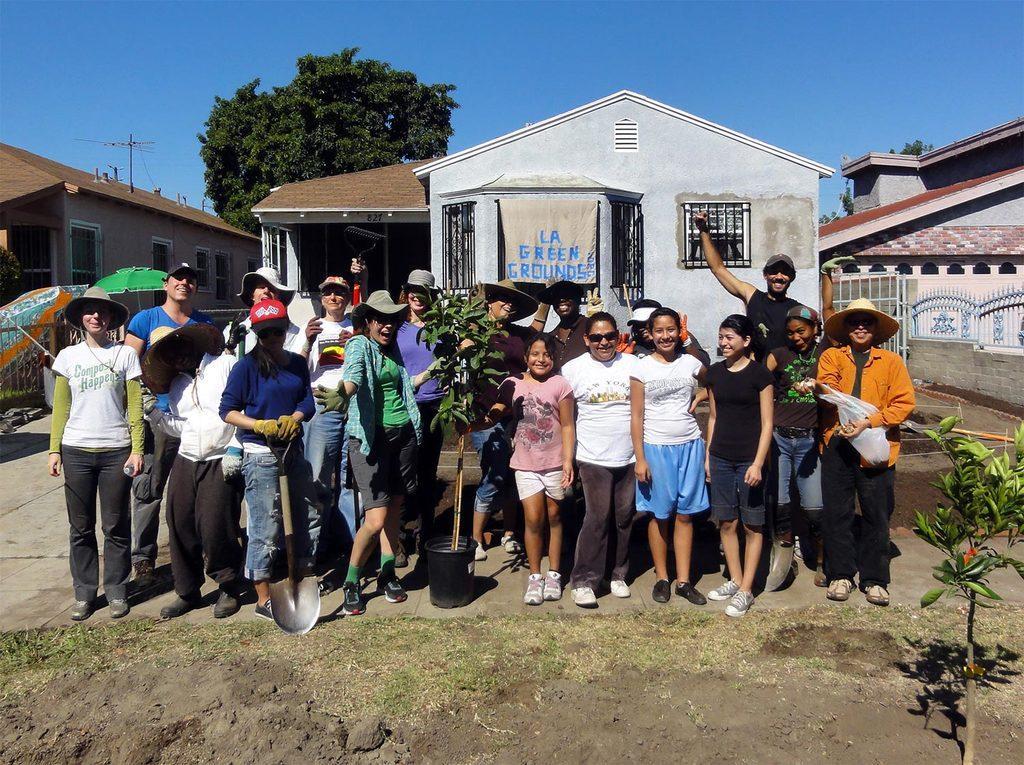How would you summarize this image in a sentence or two? In the center of the image we can see a plant in a pot. We can also see a group of people around it. In the a woman is holding a hand plow and a person holding a plant. On the right side we can see a person holding a cover. We can also see some grass and a plant with flowers. On the backside we can see some houses with roof and windows, a banner with some text on it, a metal grill, some trees, a pole with wires and the sky which looks cloudy. 